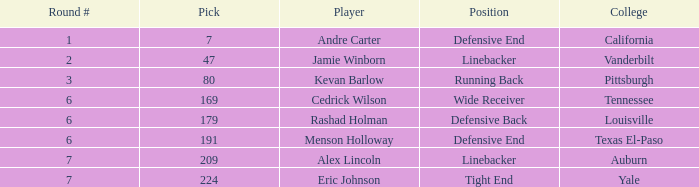Which pick came from Pittsburgh? 1.0. 